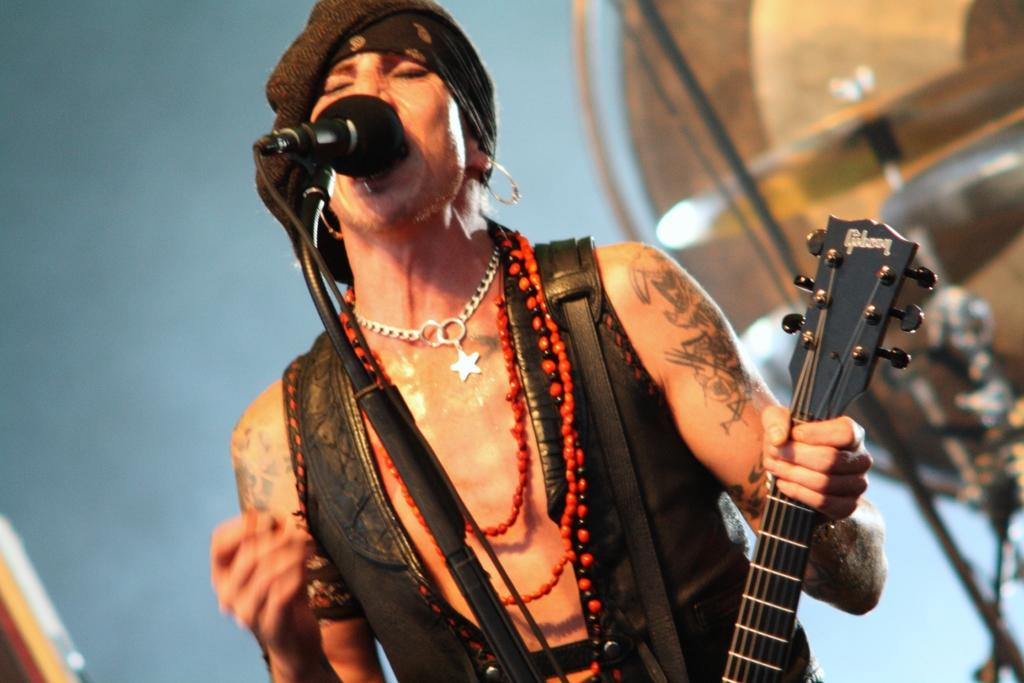What is the main subject of the image? There is a person in the image. What is the person holding in the image? The person is holding a guitar. What object is the person standing in front of? The person is standing in front of a microphone. What historical event is the person attending in the image? There is no indication of a historical event in the image; it simply shows a person holding a guitar and standing in front of a microphone. What color is the person's shirt in the image? The provided facts do not mention the color of the person's shirt, so it cannot be determined from the image. 